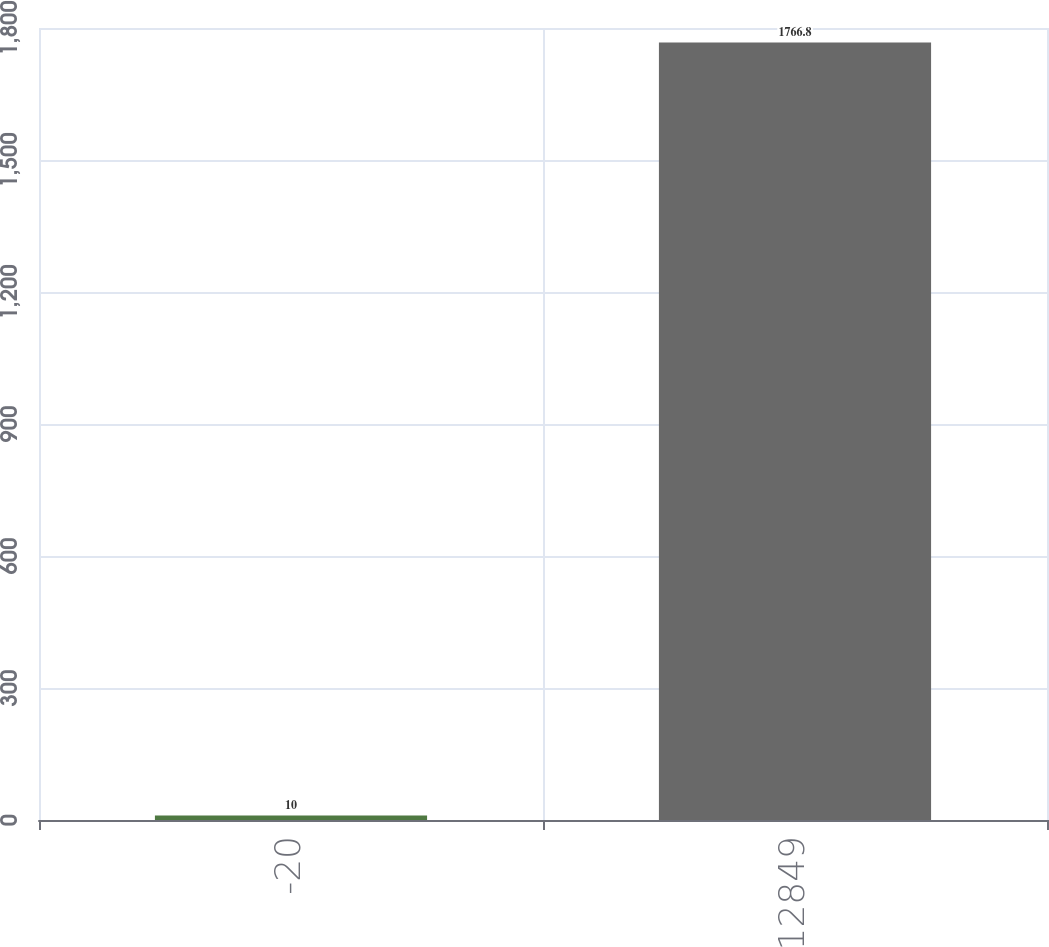Convert chart. <chart><loc_0><loc_0><loc_500><loc_500><bar_chart><fcel>-20<fcel>12849<nl><fcel>10<fcel>1766.8<nl></chart> 